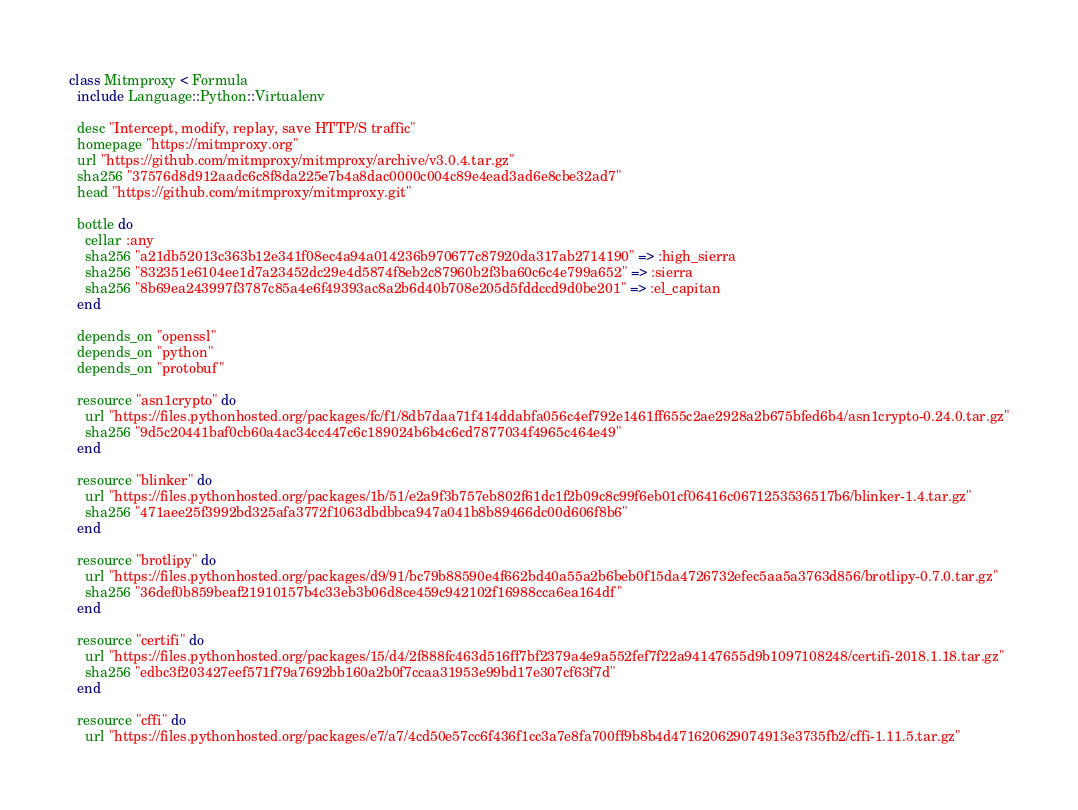Convert code to text. <code><loc_0><loc_0><loc_500><loc_500><_Ruby_>class Mitmproxy < Formula
  include Language::Python::Virtualenv

  desc "Intercept, modify, replay, save HTTP/S traffic"
  homepage "https://mitmproxy.org"
  url "https://github.com/mitmproxy/mitmproxy/archive/v3.0.4.tar.gz"
  sha256 "37576d8d912aadc6c8f8da225e7b4a8dac0000c004c89e4ead3ad6e8cbe32ad7"
  head "https://github.com/mitmproxy/mitmproxy.git"

  bottle do
    cellar :any
    sha256 "a21db52013c363b12e341f08ec4a94a014236b970677c87920da317ab2714190" => :high_sierra
    sha256 "832351e6104ee1d7a23452dc29e4d5874f8eb2c87960b2f3ba60c6c4e799a652" => :sierra
    sha256 "8b69ea243997f3787c85a4e6f49393ac8a2b6d40b708e205d5fddccd9d0be201" => :el_capitan
  end

  depends_on "openssl"
  depends_on "python"
  depends_on "protobuf"

  resource "asn1crypto" do
    url "https://files.pythonhosted.org/packages/fc/f1/8db7daa71f414ddabfa056c4ef792e1461ff655c2ae2928a2b675bfed6b4/asn1crypto-0.24.0.tar.gz"
    sha256 "9d5c20441baf0cb60a4ac34cc447c6c189024b6b4c6cd7877034f4965c464e49"
  end

  resource "blinker" do
    url "https://files.pythonhosted.org/packages/1b/51/e2a9f3b757eb802f61dc1f2b09c8c99f6eb01cf06416c0671253536517b6/blinker-1.4.tar.gz"
    sha256 "471aee25f3992bd325afa3772f1063dbdbbca947a041b8b89466dc00d606f8b6"
  end

  resource "brotlipy" do
    url "https://files.pythonhosted.org/packages/d9/91/bc79b88590e4f662bd40a55a2b6beb0f15da4726732efec5aa5a3763d856/brotlipy-0.7.0.tar.gz"
    sha256 "36def0b859beaf21910157b4c33eb3b06d8ce459c942102f16988cca6ea164df"
  end

  resource "certifi" do
    url "https://files.pythonhosted.org/packages/15/d4/2f888fc463d516ff7bf2379a4e9a552fef7f22a94147655d9b1097108248/certifi-2018.1.18.tar.gz"
    sha256 "edbc3f203427eef571f79a7692bb160a2b0f7ccaa31953e99bd17e307cf63f7d"
  end

  resource "cffi" do
    url "https://files.pythonhosted.org/packages/e7/a7/4cd50e57cc6f436f1cc3a7e8fa700ff9b8b4d471620629074913e3735fb2/cffi-1.11.5.tar.gz"</code> 